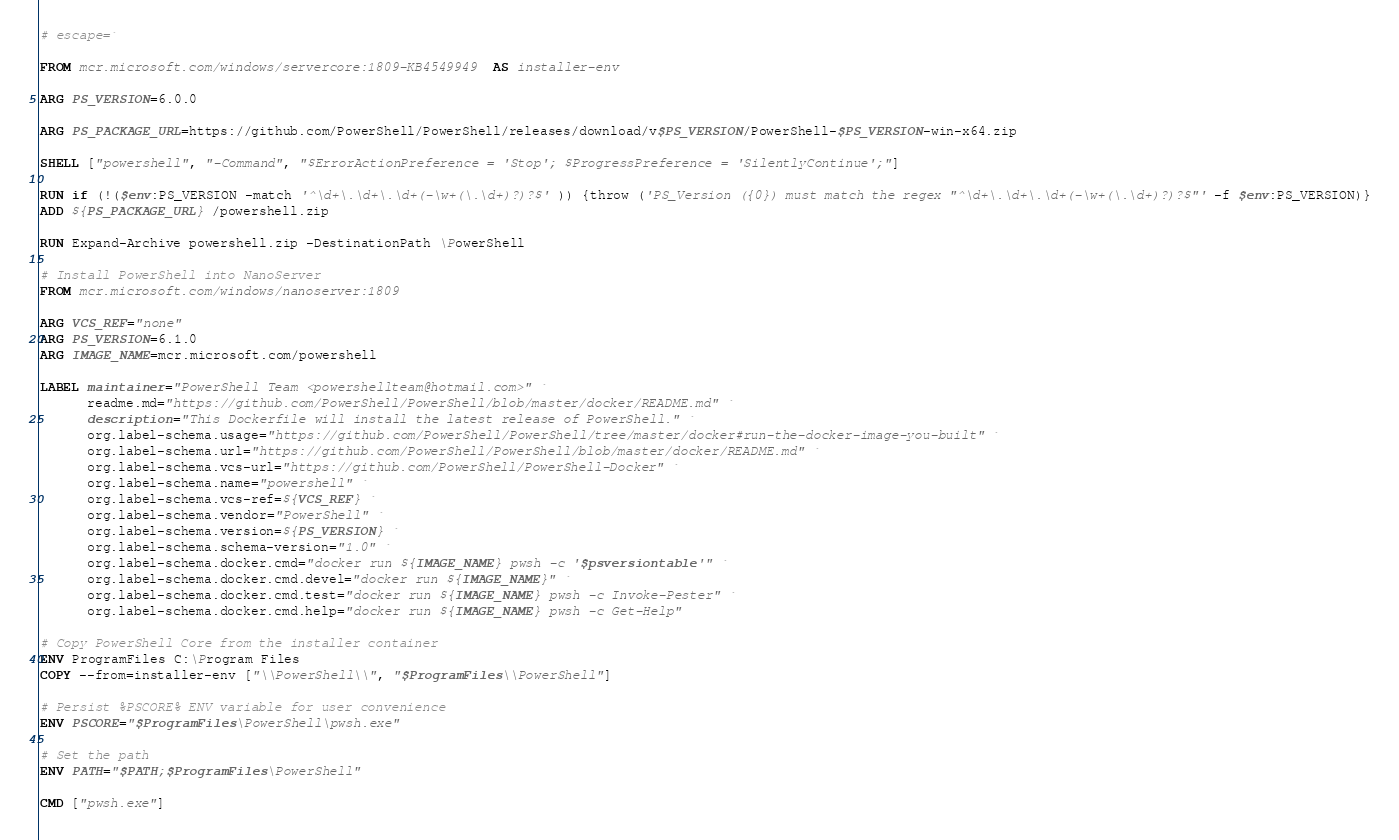<code> <loc_0><loc_0><loc_500><loc_500><_Dockerfile_># escape=`

FROM mcr.microsoft.com/windows/servercore:1809-KB4549949  AS installer-env

ARG PS_VERSION=6.0.0

ARG PS_PACKAGE_URL=https://github.com/PowerShell/PowerShell/releases/download/v$PS_VERSION/PowerShell-$PS_VERSION-win-x64.zip

SHELL ["powershell", "-Command", "$ErrorActionPreference = 'Stop'; $ProgressPreference = 'SilentlyContinue';"]

RUN if (!($env:PS_VERSION -match '^\d+\.\d+\.\d+(-\w+(\.\d+)?)?$' )) {throw ('PS_Version ({0}) must match the regex "^\d+\.\d+\.\d+(-\w+(\.\d+)?)?$"' -f $env:PS_VERSION)}
ADD ${PS_PACKAGE_URL} /powershell.zip

RUN Expand-Archive powershell.zip -DestinationPath \PowerShell

# Install PowerShell into NanoServer
FROM mcr.microsoft.com/windows/nanoserver:1809

ARG VCS_REF="none"
ARG PS_VERSION=6.1.0
ARG IMAGE_NAME=mcr.microsoft.com/powershell

LABEL maintainer="PowerShell Team <powershellteam@hotmail.com>" `
      readme.md="https://github.com/PowerShell/PowerShell/blob/master/docker/README.md" `
      description="This Dockerfile will install the latest release of PowerShell." `
      org.label-schema.usage="https://github.com/PowerShell/PowerShell/tree/master/docker#run-the-docker-image-you-built" `
      org.label-schema.url="https://github.com/PowerShell/PowerShell/blob/master/docker/README.md" `
      org.label-schema.vcs-url="https://github.com/PowerShell/PowerShell-Docker" `
      org.label-schema.name="powershell" `
      org.label-schema.vcs-ref=${VCS_REF} `
      org.label-schema.vendor="PowerShell" `
      org.label-schema.version=${PS_VERSION} `
      org.label-schema.schema-version="1.0" `
      org.label-schema.docker.cmd="docker run ${IMAGE_NAME} pwsh -c '$psversiontable'" `
      org.label-schema.docker.cmd.devel="docker run ${IMAGE_NAME}" `
      org.label-schema.docker.cmd.test="docker run ${IMAGE_NAME} pwsh -c Invoke-Pester" `
      org.label-schema.docker.cmd.help="docker run ${IMAGE_NAME} pwsh -c Get-Help"

# Copy PowerShell Core from the installer container
ENV ProgramFiles C:\Program Files
COPY --from=installer-env ["\\PowerShell\\", "$ProgramFiles\\PowerShell"]

# Persist %PSCORE% ENV variable for user convenience
ENV PSCORE="$ProgramFiles\PowerShell\pwsh.exe"

# Set the path
ENV PATH="$PATH;$ProgramFiles\PowerShell"

CMD ["pwsh.exe"]
</code> 